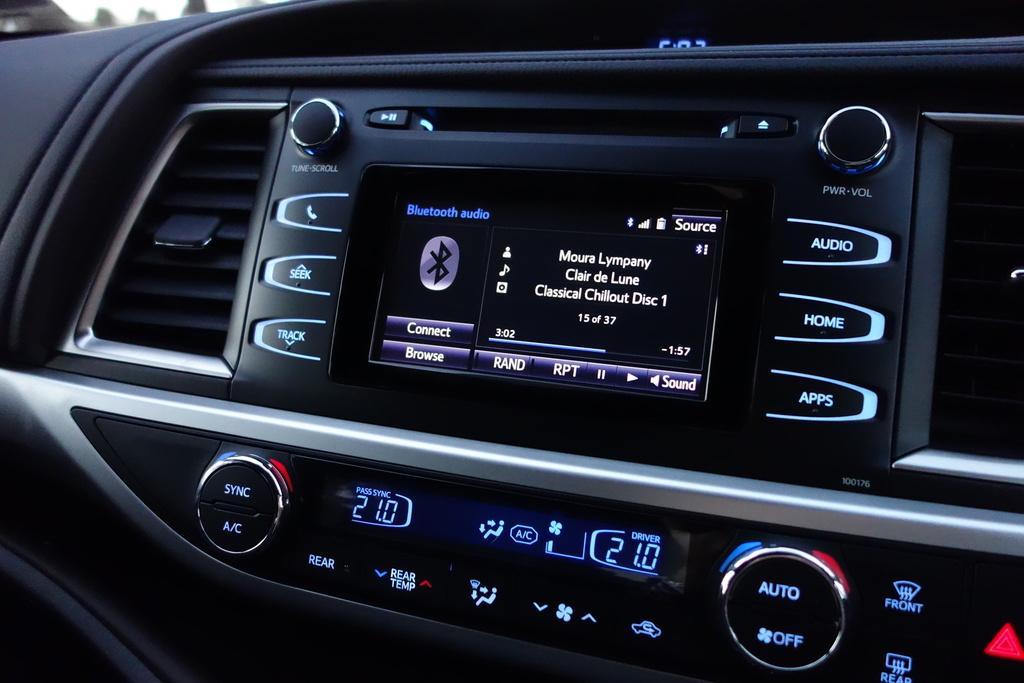Could you give a brief overview of what you see in this image? In this image I can see a car music system. It is in black color and few button on it. 